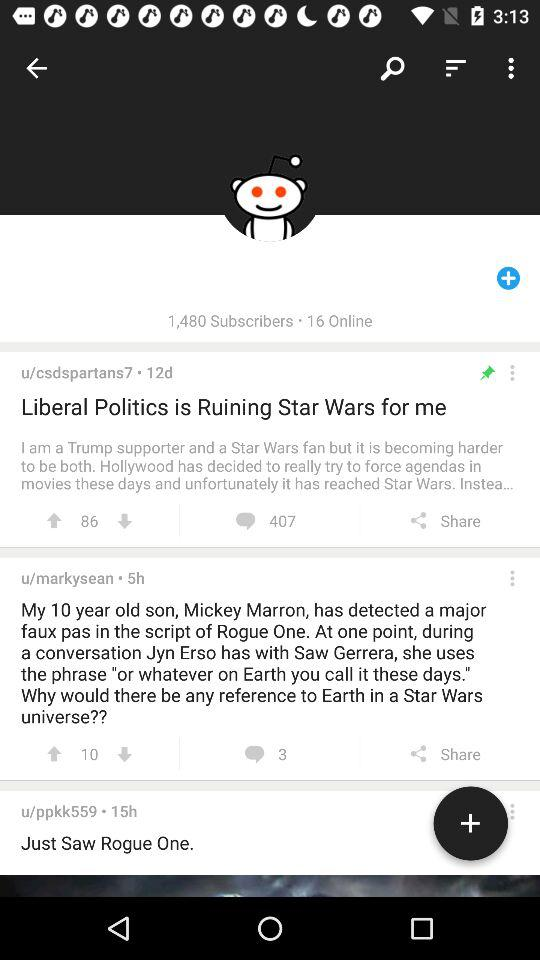How many people are online? There are 16 people online. 